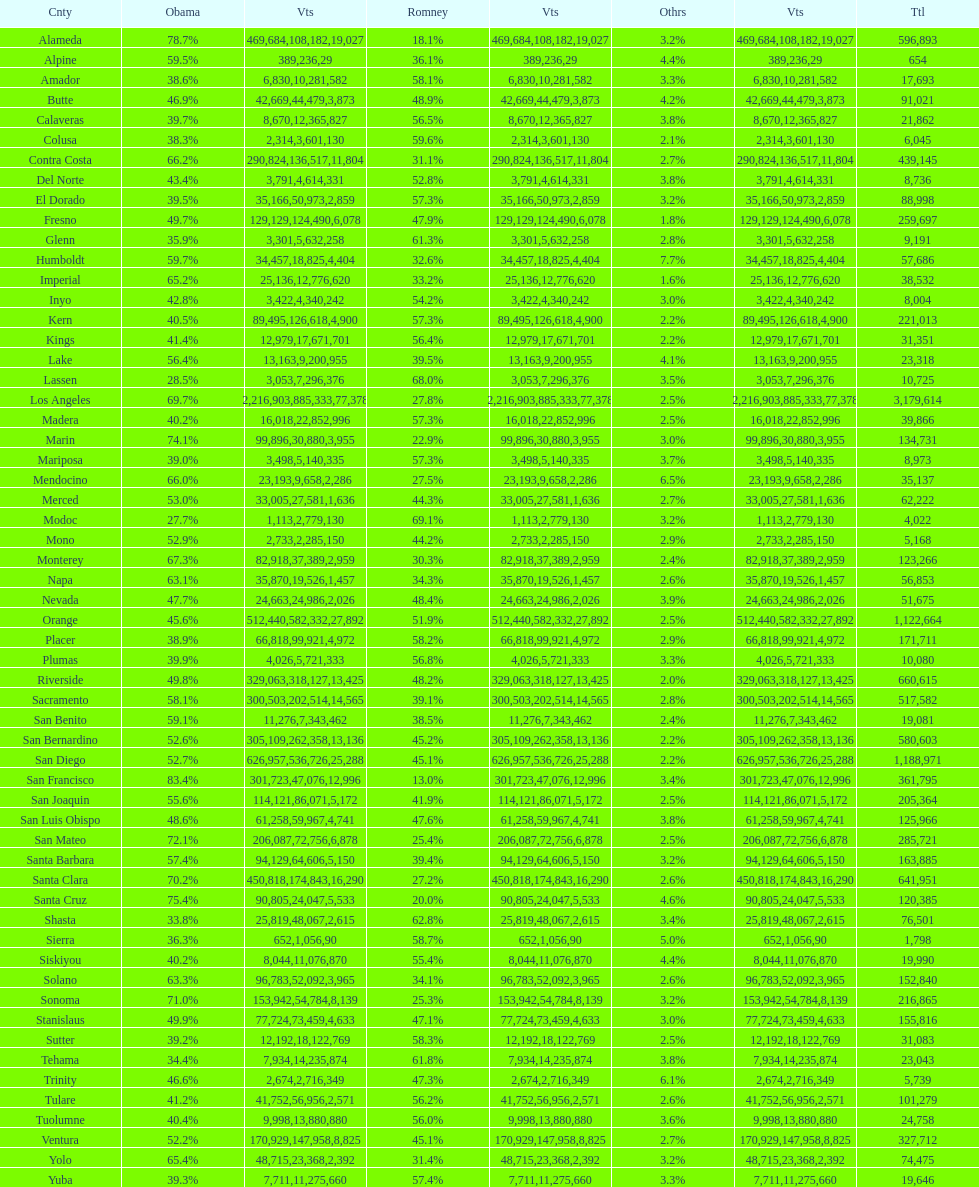Which count had the least number of votes for obama? Modoc. 